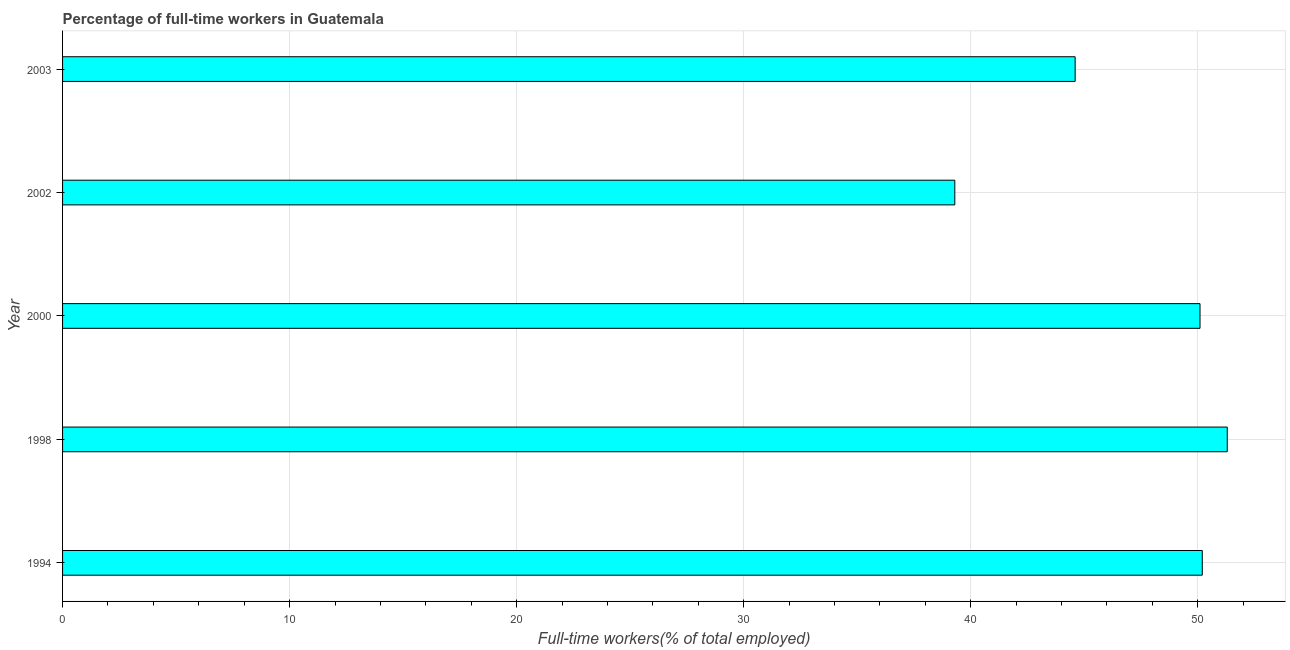Does the graph contain grids?
Offer a very short reply. Yes. What is the title of the graph?
Provide a succinct answer. Percentage of full-time workers in Guatemala. What is the label or title of the X-axis?
Make the answer very short. Full-time workers(% of total employed). What is the label or title of the Y-axis?
Your answer should be very brief. Year. What is the percentage of full-time workers in 1994?
Your response must be concise. 50.2. Across all years, what is the maximum percentage of full-time workers?
Offer a terse response. 51.3. Across all years, what is the minimum percentage of full-time workers?
Your answer should be compact. 39.3. What is the sum of the percentage of full-time workers?
Your response must be concise. 235.5. What is the difference between the percentage of full-time workers in 2002 and 2003?
Your response must be concise. -5.3. What is the average percentage of full-time workers per year?
Your answer should be very brief. 47.1. What is the median percentage of full-time workers?
Provide a short and direct response. 50.1. What is the ratio of the percentage of full-time workers in 1998 to that in 2002?
Your answer should be compact. 1.3. Is the percentage of full-time workers in 2000 less than that in 2003?
Your answer should be compact. No. Is the difference between the percentage of full-time workers in 1998 and 2002 greater than the difference between any two years?
Provide a short and direct response. Yes. How many bars are there?
Your answer should be very brief. 5. What is the difference between two consecutive major ticks on the X-axis?
Your answer should be compact. 10. Are the values on the major ticks of X-axis written in scientific E-notation?
Provide a succinct answer. No. What is the Full-time workers(% of total employed) in 1994?
Provide a short and direct response. 50.2. What is the Full-time workers(% of total employed) of 1998?
Make the answer very short. 51.3. What is the Full-time workers(% of total employed) of 2000?
Offer a terse response. 50.1. What is the Full-time workers(% of total employed) of 2002?
Offer a terse response. 39.3. What is the Full-time workers(% of total employed) in 2003?
Ensure brevity in your answer.  44.6. What is the difference between the Full-time workers(% of total employed) in 1994 and 2002?
Provide a succinct answer. 10.9. What is the difference between the Full-time workers(% of total employed) in 2000 and 2003?
Offer a very short reply. 5.5. What is the difference between the Full-time workers(% of total employed) in 2002 and 2003?
Your answer should be compact. -5.3. What is the ratio of the Full-time workers(% of total employed) in 1994 to that in 1998?
Offer a terse response. 0.98. What is the ratio of the Full-time workers(% of total employed) in 1994 to that in 2000?
Provide a short and direct response. 1. What is the ratio of the Full-time workers(% of total employed) in 1994 to that in 2002?
Make the answer very short. 1.28. What is the ratio of the Full-time workers(% of total employed) in 1994 to that in 2003?
Give a very brief answer. 1.13. What is the ratio of the Full-time workers(% of total employed) in 1998 to that in 2002?
Offer a very short reply. 1.3. What is the ratio of the Full-time workers(% of total employed) in 1998 to that in 2003?
Keep it short and to the point. 1.15. What is the ratio of the Full-time workers(% of total employed) in 2000 to that in 2002?
Offer a terse response. 1.27. What is the ratio of the Full-time workers(% of total employed) in 2000 to that in 2003?
Provide a succinct answer. 1.12. What is the ratio of the Full-time workers(% of total employed) in 2002 to that in 2003?
Offer a very short reply. 0.88. 